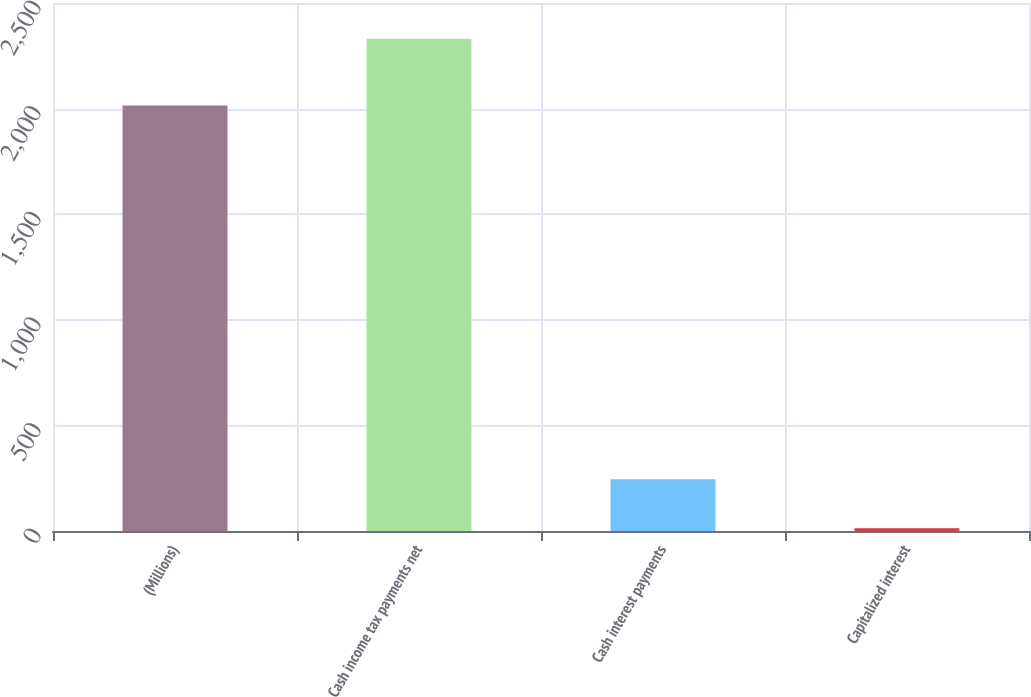<chart> <loc_0><loc_0><loc_500><loc_500><bar_chart><fcel>(Millions)<fcel>Cash income tax payments net<fcel>Cash interest payments<fcel>Capitalized interest<nl><fcel>2015<fcel>2331<fcel>244.8<fcel>13<nl></chart> 